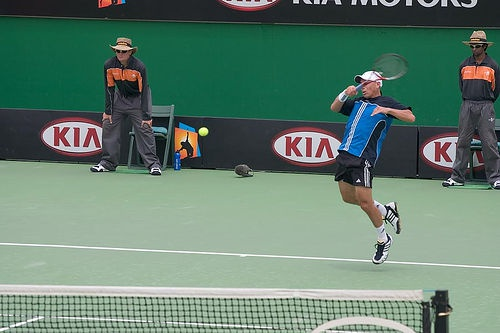Describe the objects in this image and their specific colors. I can see people in black, blue, and gray tones, people in black, gray, and teal tones, people in black, gray, and teal tones, tennis racket in black, teal, lavender, and darkgray tones, and chair in black, gray, and teal tones in this image. 